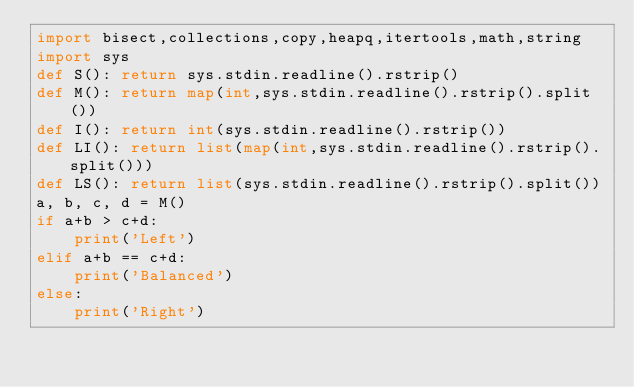<code> <loc_0><loc_0><loc_500><loc_500><_Python_>import bisect,collections,copy,heapq,itertools,math,string
import sys
def S(): return sys.stdin.readline().rstrip()
def M(): return map(int,sys.stdin.readline().rstrip().split())
def I(): return int(sys.stdin.readline().rstrip())
def LI(): return list(map(int,sys.stdin.readline().rstrip().split()))
def LS(): return list(sys.stdin.readline().rstrip().split())
a, b, c, d = M()
if a+b > c+d:
    print('Left')
elif a+b == c+d:
    print('Balanced')
else:
    print('Right')</code> 